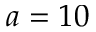<formula> <loc_0><loc_0><loc_500><loc_500>a = 1 0</formula> 